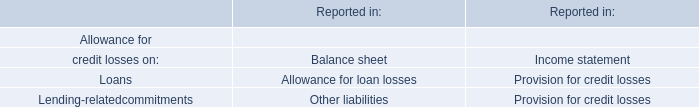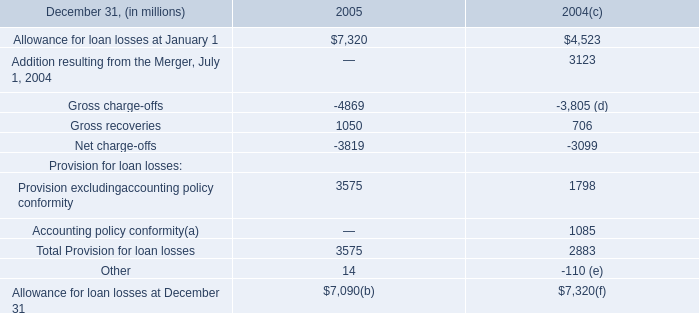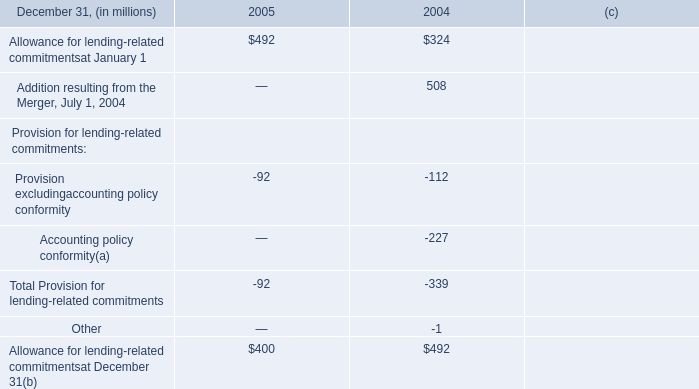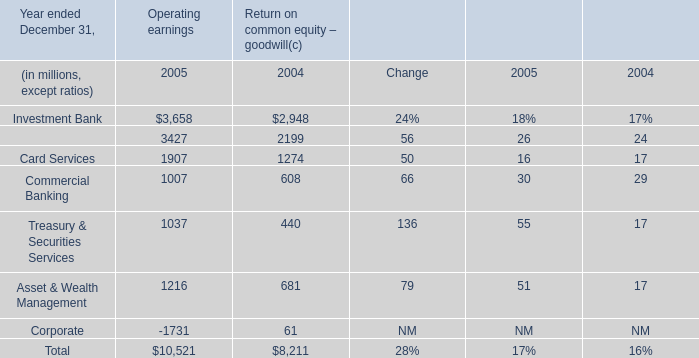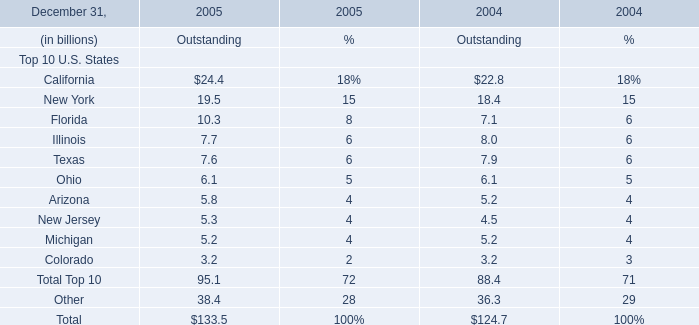What is the proportion of New York to the total in 2005 ? 
Computations: (19.5 / 133.5)
Answer: 0.14607. 